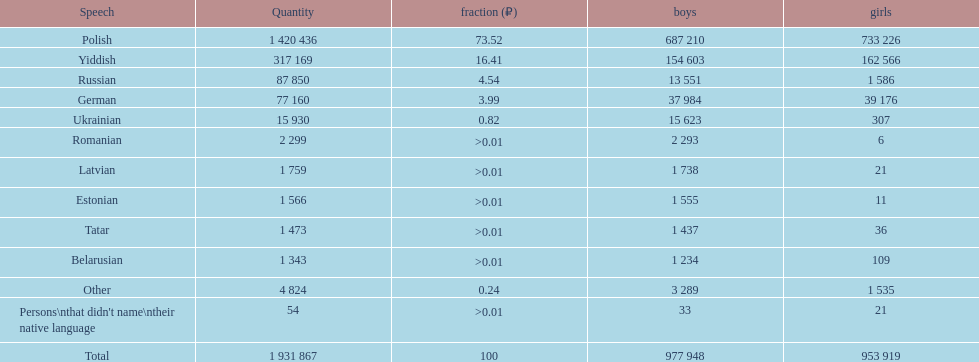Number of male russian speakers 13 551. 